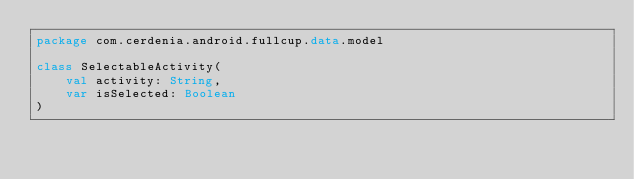Convert code to text. <code><loc_0><loc_0><loc_500><loc_500><_Kotlin_>package com.cerdenia.android.fullcup.data.model

class SelectableActivity(
    val activity: String,
    var isSelected: Boolean
)</code> 